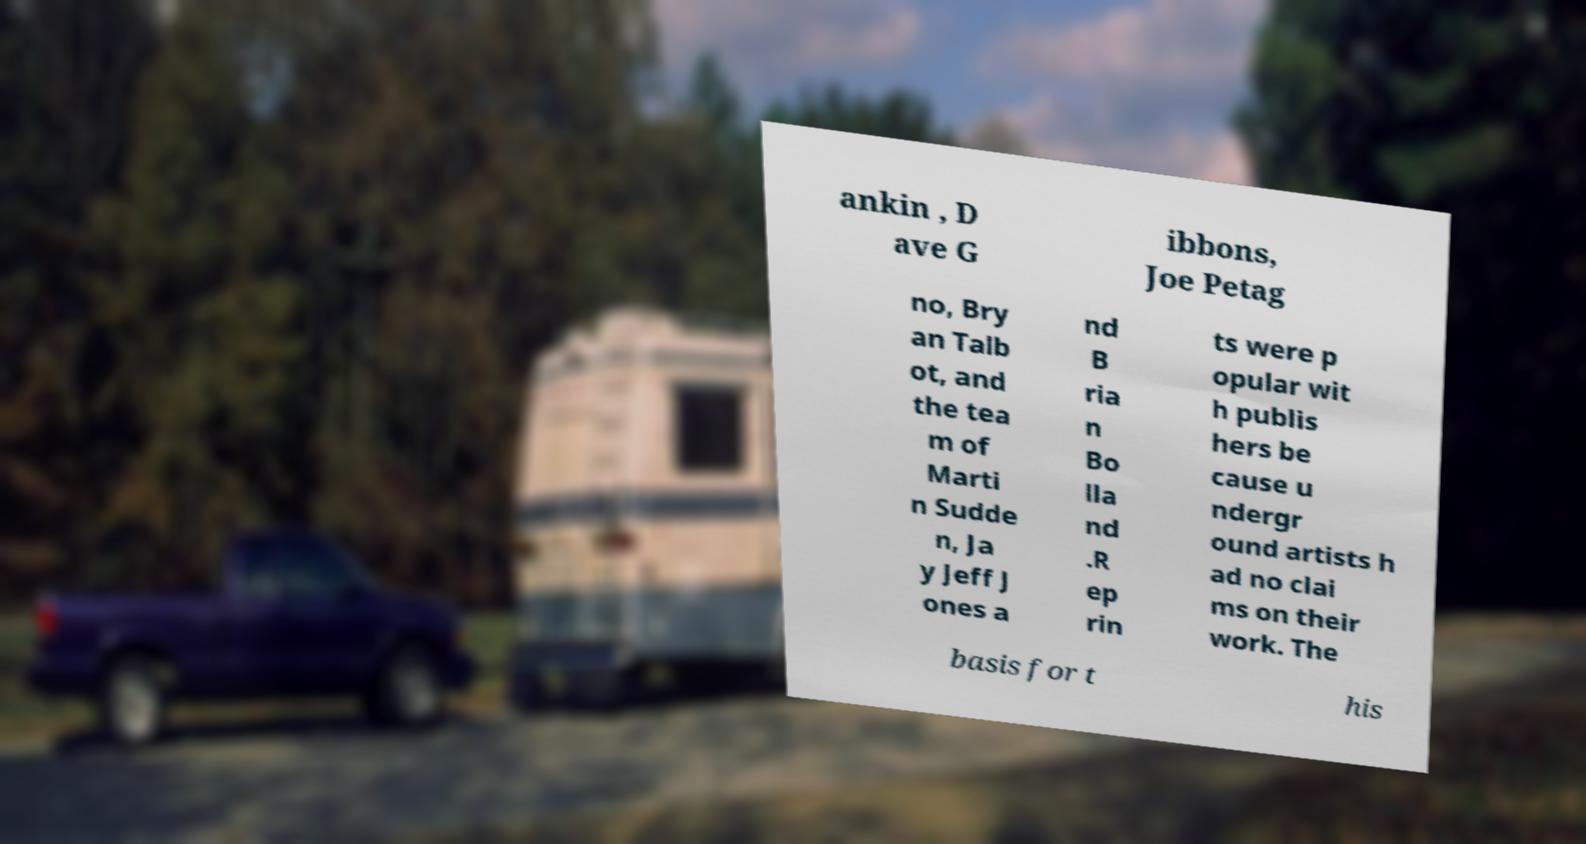Please read and relay the text visible in this image. What does it say? ankin , D ave G ibbons, Joe Petag no, Bry an Talb ot, and the tea m of Marti n Sudde n, Ja y Jeff J ones a nd B ria n Bo lla nd .R ep rin ts were p opular wit h publis hers be cause u ndergr ound artists h ad no clai ms on their work. The basis for t his 